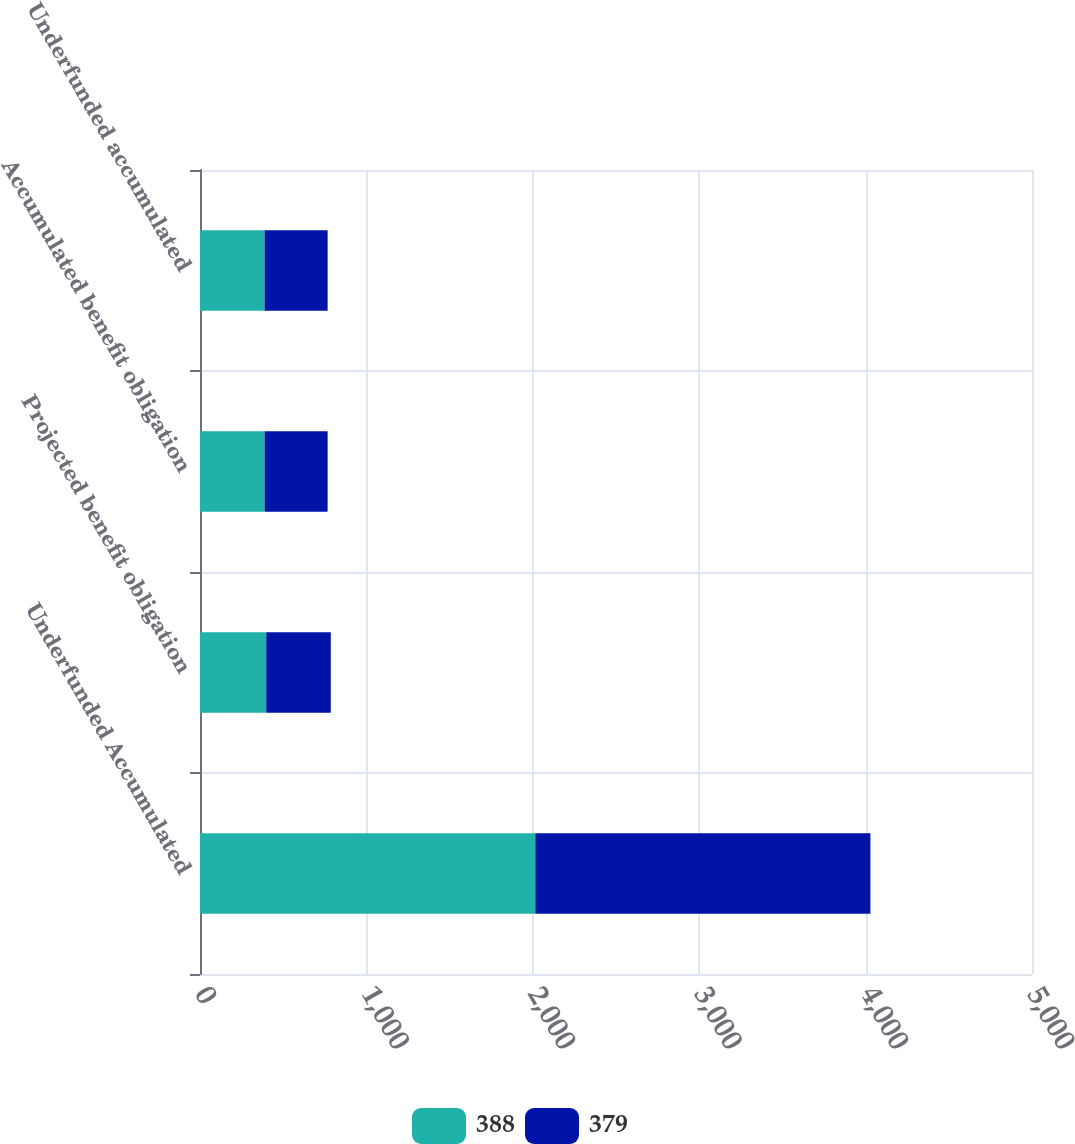Convert chart. <chart><loc_0><loc_0><loc_500><loc_500><stacked_bar_chart><ecel><fcel>Underfunded Accumulated<fcel>Projected benefit obligation<fcel>Accumulated benefit obligation<fcel>Underfunded accumulated<nl><fcel>388<fcel>2015<fcel>398<fcel>388<fcel>388<nl><fcel>379<fcel>2014<fcel>388<fcel>379<fcel>379<nl></chart> 